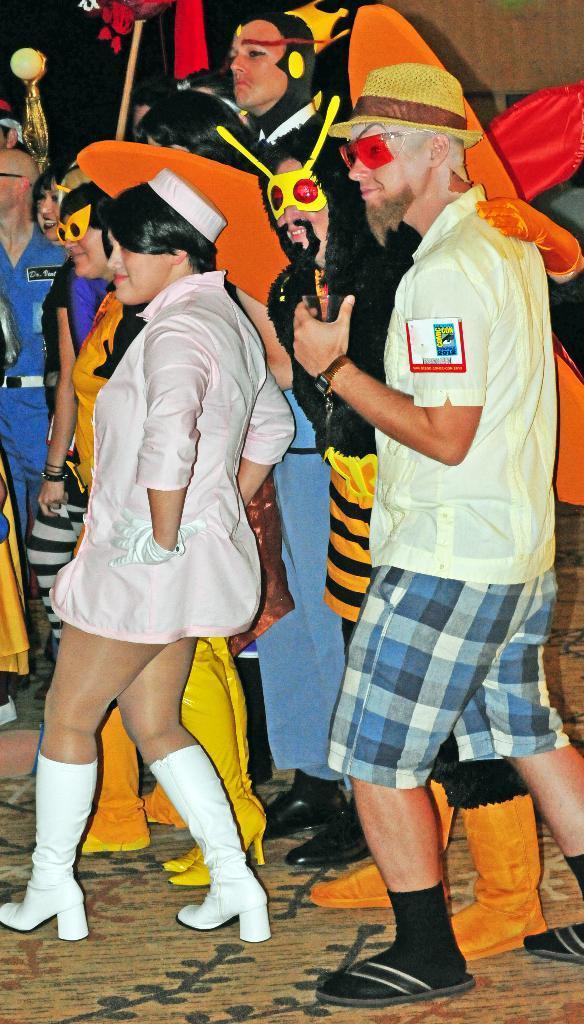How would you summarize this image in a sentence or two? In this picture we can see two people smiling, some people wore costumes and they all are standing on the ground and in the background we can see some objects. 